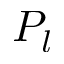Convert formula to latex. <formula><loc_0><loc_0><loc_500><loc_500>P _ { l }</formula> 